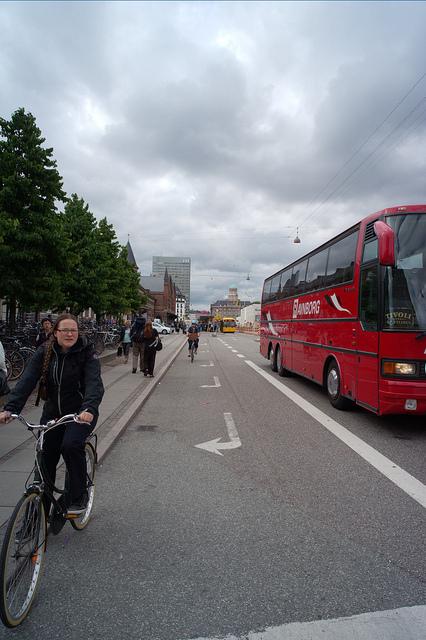What color is the stripe?
Be succinct. White. What hand drive is the traffic in this scene?
Keep it brief. Right. What is behind the bike?
Answer briefly. People. What are the lines on the parking lot for?
Short answer required. Organization. How many bikes are there?
Answer briefly. 1. What do the racers have on their heads?
Give a very brief answer. Nothing. What is the person doing?
Quick response, please. Biking. How many wheels do the vehicles on the left have?
Quick response, please. 2. What color is the front of the bus?
Be succinct. Red. What structure is the biker on?
Concise answer only. Street. What color is the car?
Answer briefly. Red. In which direction is the arrow of the street pointing?
Concise answer only. Right. What kind of bike is this?
Short answer required. Bicycle. Is the woman driving?
Short answer required. No. What bus number is shown?
Answer briefly. 0. Where are they?
Give a very brief answer. Street. Is it overcast?
Give a very brief answer. Yes. What is the woman doing?
Concise answer only. Riding bike. How many people are in this picture?
Quick response, please. 5. What color are the lines on the road?
Concise answer only. White. Is the road straight?
Quick response, please. Yes. Do both rider have on helmets?
Short answer required. No. What collection is this image from?
Keep it brief. Bus. Can the bus turn right in the lane it is currently in?
Give a very brief answer. No. What color are the road lines?
Short answer required. White. What color is the moving truck?
Quick response, please. Red. How many people are on the bike?
Short answer required. 1. Is the ground wet?
Give a very brief answer. No. What type of transportation is this?
Be succinct. Bus. Are these people going to get on the bus?
Write a very short answer. No. What type of vehicle is this?
Concise answer only. Bus. What modes of transportation are present?
Quick response, please. Bike and bus. What color is the bus?
Give a very brief answer. Red. What vehicle is this person riding?
Keep it brief. Bicycle. Is there anything strange about the figure riding the bicycle?
Answer briefly. No. What kind of vehicle is shown?
Write a very short answer. Bus. Is there a sign?
Concise answer only. No. Is the woman carrying a shopping bag?
Quick response, please. No. What kind of vehicle is this?
Write a very short answer. Bus. Is the day Sunny?
Give a very brief answer. No. What is the weather like?
Keep it brief. Cloudy. What is the woman sitting on?
Keep it brief. Bike. 